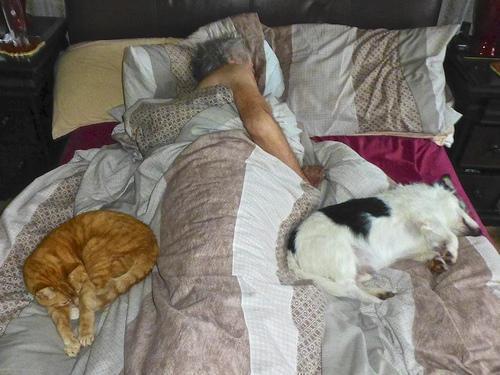How many animals are there?
Give a very brief answer. 2. 